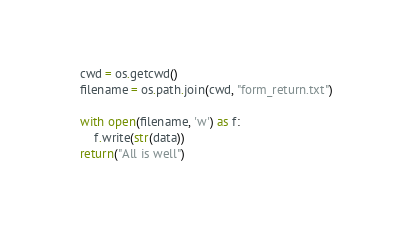<code> <loc_0><loc_0><loc_500><loc_500><_Python_>    cwd = os.getcwd()
    filename = os.path.join(cwd, "form_return.txt")

    with open(filename, 'w') as f:
        f.write(str(data))
    return("All is well")
</code> 